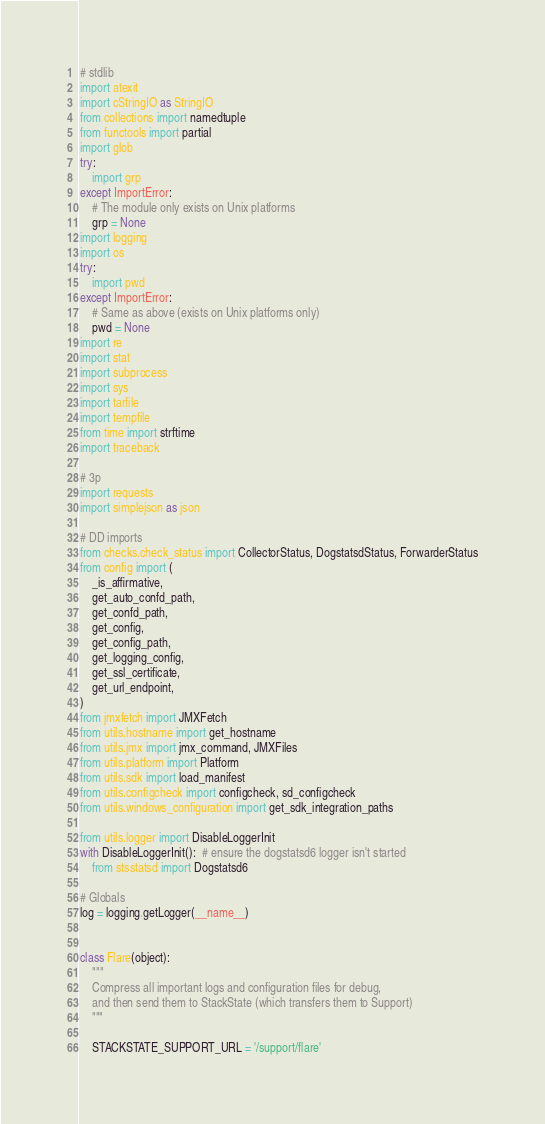Convert code to text. <code><loc_0><loc_0><loc_500><loc_500><_Python_>
# stdlib
import atexit
import cStringIO as StringIO
from collections import namedtuple
from functools import partial
import glob
try:
    import grp
except ImportError:
    # The module only exists on Unix platforms
    grp = None
import logging
import os
try:
    import pwd
except ImportError:
    # Same as above (exists on Unix platforms only)
    pwd = None
import re
import stat
import subprocess
import sys
import tarfile
import tempfile
from time import strftime
import traceback

# 3p
import requests
import simplejson as json

# DD imports
from checks.check_status import CollectorStatus, DogstatsdStatus, ForwarderStatus
from config import (
    _is_affirmative,
    get_auto_confd_path,
    get_confd_path,
    get_config,
    get_config_path,
    get_logging_config,
    get_ssl_certificate,
    get_url_endpoint,
)
from jmxfetch import JMXFetch
from utils.hostname import get_hostname
from utils.jmx import jmx_command, JMXFiles
from utils.platform import Platform
from utils.sdk import load_manifest
from utils.configcheck import configcheck, sd_configcheck
from utils.windows_configuration import get_sdk_integration_paths

from utils.logger import DisableLoggerInit
with DisableLoggerInit():  # ensure the dogstatsd6 logger isn't started
    from stsstatsd import Dogstatsd6

# Globals
log = logging.getLogger(__name__)


class Flare(object):
    """
    Compress all important logs and configuration files for debug,
    and then send them to StackState (which transfers them to Support)
    """

    STACKSTATE_SUPPORT_URL = '/support/flare'
</code> 